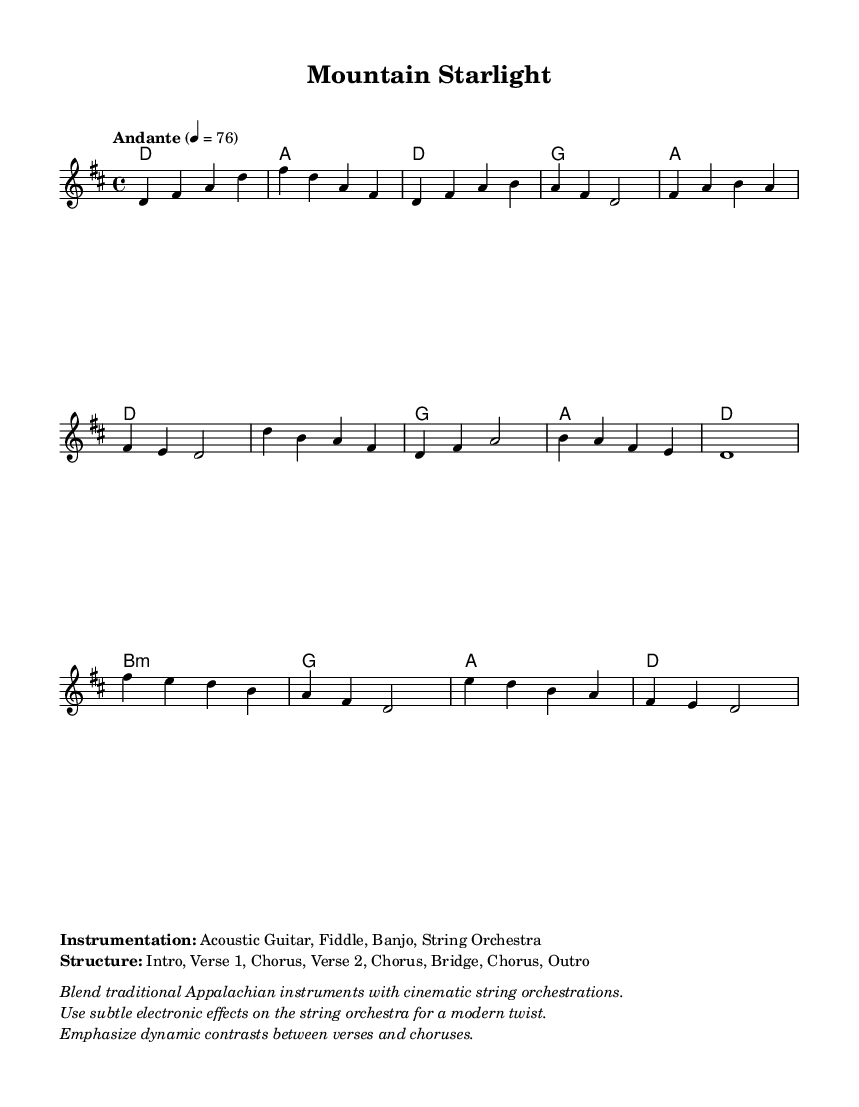What is the key signature of this music? The key signature is D major, which has two sharps (F# and C#) indicated at the beginning of the staff.
Answer: D major What is the time signature of this music? The time signature shown is 4/4, indicating four beats per measure, which is a standard time signature for folk music.
Answer: 4/4 What is the tempo marking for this piece? The tempo marking is "Andante" with a metronome marking of 76 beats per minute, suggesting a moderately slow and flowing pace.
Answer: Andante How many verses are present in the structure? The structure includes two verses as indicated by the sections labeled "Verse 1" and "Verse 2" in the markup.
Answer: 2 What is the instrumentation used in this composition? The instrumentation listed includes Acoustic Guitar, Fiddle, Banjo, and String Orchestra, combining traditional folk elements with orchestral sounds.
Answer: Acoustic Guitar, Fiddle, Banjo, String Orchestra What type of harmonic progression is primarily used in the chorus? The chorus primarily employs a progression using D, G, A, and D chords, which are common in folk music to create a strong foundation for the melody.
Answer: D, G, A, D What modern elements are suggested for the string orchestra? The notation mentions that subtle electronic effects should be used on the string orchestra for a modern twist, enhancing the traditional sound.
Answer: Subtle electronic effects 